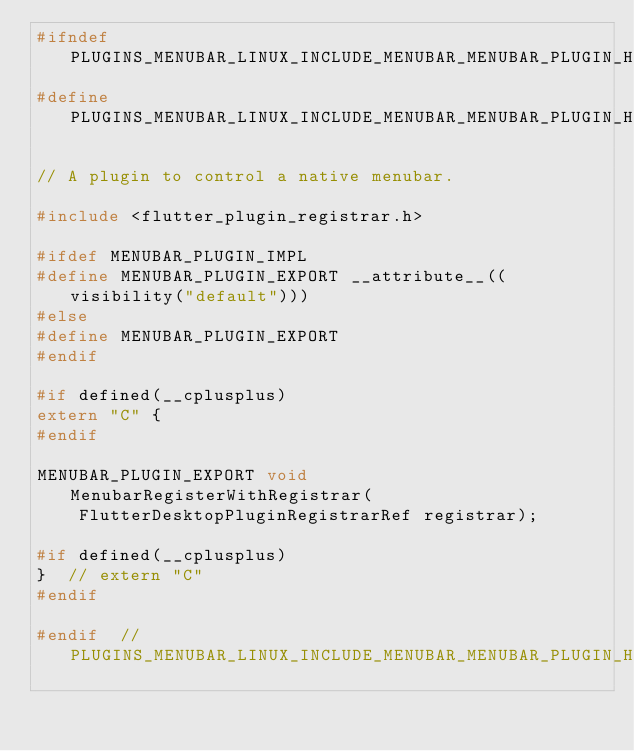Convert code to text. <code><loc_0><loc_0><loc_500><loc_500><_C_>#ifndef PLUGINS_MENUBAR_LINUX_INCLUDE_MENUBAR_MENUBAR_PLUGIN_H_
#define PLUGINS_MENUBAR_LINUX_INCLUDE_MENUBAR_MENUBAR_PLUGIN_H_

// A plugin to control a native menubar.

#include <flutter_plugin_registrar.h>

#ifdef MENUBAR_PLUGIN_IMPL
#define MENUBAR_PLUGIN_EXPORT __attribute__((visibility("default")))
#else
#define MENUBAR_PLUGIN_EXPORT
#endif

#if defined(__cplusplus)
extern "C" {
#endif

MENUBAR_PLUGIN_EXPORT void MenubarRegisterWithRegistrar(
    FlutterDesktopPluginRegistrarRef registrar);

#if defined(__cplusplus)
}  // extern "C"
#endif

#endif  // PLUGINS_MENUBAR_LINUX_INCLUDE_MENUBAR_MENUBAR_PLUGIN_H_
</code> 